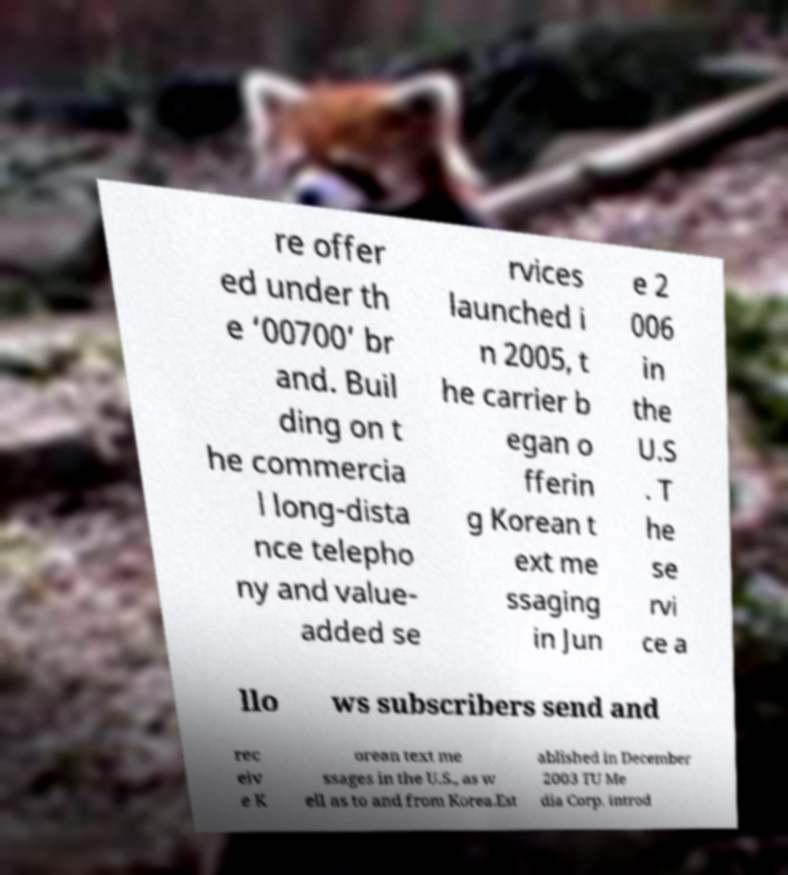Please read and relay the text visible in this image. What does it say? re offer ed under th e ‘00700’ br and. Buil ding on t he commercia l long-dista nce telepho ny and value- added se rvices launched i n 2005, t he carrier b egan o fferin g Korean t ext me ssaging in Jun e 2 006 in the U.S . T he se rvi ce a llo ws subscribers send and rec eiv e K orean text me ssages in the U.S., as w ell as to and from Korea.Est ablished in December 2003 TU Me dia Corp. introd 